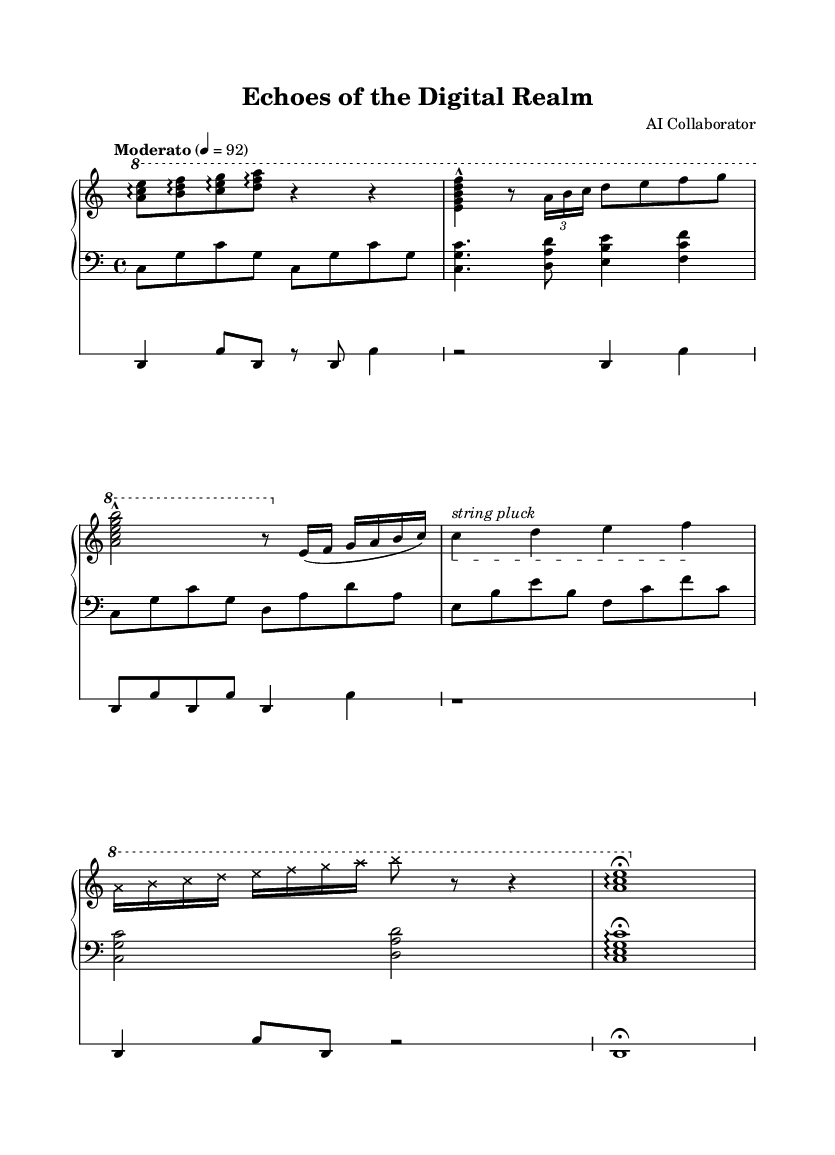What is the time signature of this piece? The time signature is indicated in the beginning of the upper staff as 4/4, which means there are four beats in each measure.
Answer: 4/4 What is the tempo marking for this composition? The tempo marking is found at the beginning of the upper staff, marked as "Moderato" with a metronome marking of 92, indicating a moderate speed.
Answer: Moderato, 92 What instrument techniques are employed in the interlude? The interlude section specifies "string pluck" which indicates the use of extended techniques on the piano to produce non-traditional sounds.
Answer: String pluck How many sections are there in the composition? The composition can be analyzed into five distinct sections: Introduction, Section A, Section B, Interlude, Section A' (variation), and Coda.
Answer: Five What type of electronic elements are used in the piece? The electronic elements are represented in the DrumStaff section, which features a bass drum and snare drum, typically used for rhythmic support in electronic music.
Answer: Bass drum and snare drum What is the dynamic marking at the start of the upper staff? The upper staff does not explicitly show any dynamic markings at the start; it leads into the introduction section without indication, which is typical for experimental pieces that may focus on expression over strict dynamics.
Answer: None 